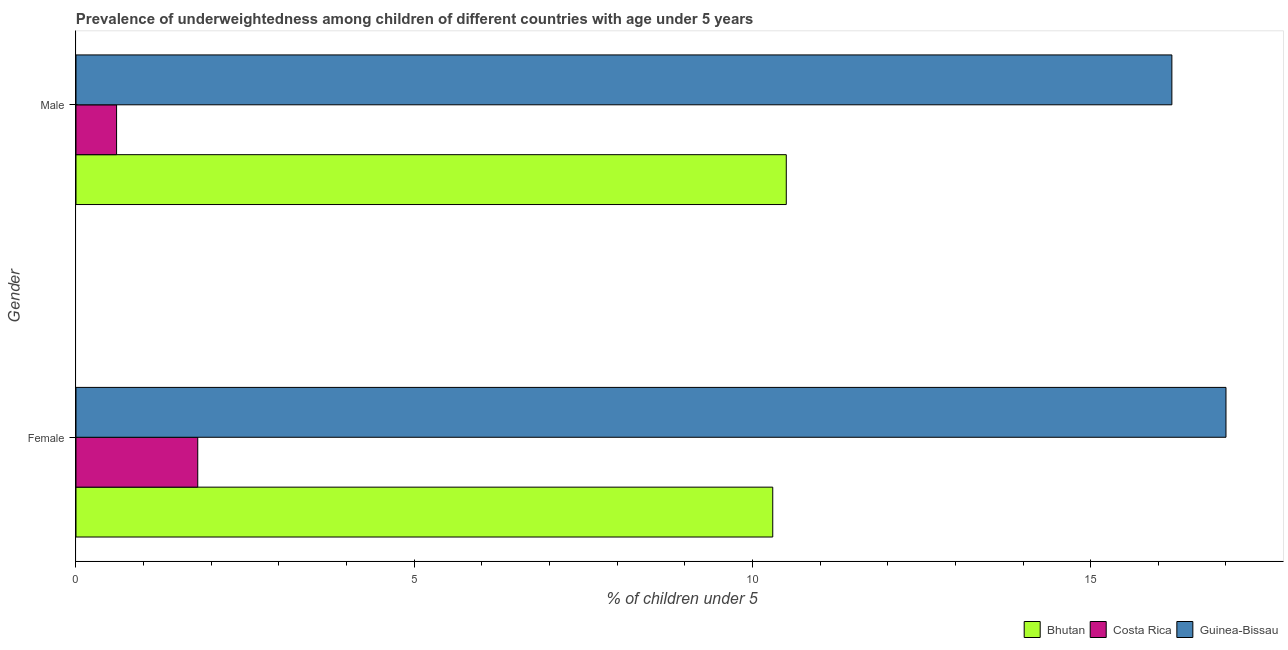Are the number of bars per tick equal to the number of legend labels?
Provide a succinct answer. Yes. How many bars are there on the 2nd tick from the bottom?
Your response must be concise. 3. What is the label of the 1st group of bars from the top?
Give a very brief answer. Male. What is the percentage of underweighted male children in Costa Rica?
Provide a short and direct response. 0.6. Across all countries, what is the maximum percentage of underweighted male children?
Offer a very short reply. 16.2. Across all countries, what is the minimum percentage of underweighted female children?
Your answer should be very brief. 1.8. In which country was the percentage of underweighted male children maximum?
Offer a terse response. Guinea-Bissau. What is the total percentage of underweighted male children in the graph?
Your answer should be very brief. 27.3. What is the difference between the percentage of underweighted male children in Bhutan and that in Guinea-Bissau?
Make the answer very short. -5.7. What is the difference between the percentage of underweighted male children in Bhutan and the percentage of underweighted female children in Costa Rica?
Provide a short and direct response. 8.7. What is the average percentage of underweighted female children per country?
Make the answer very short. 9.7. What is the difference between the percentage of underweighted male children and percentage of underweighted female children in Bhutan?
Your answer should be very brief. 0.2. In how many countries, is the percentage of underweighted female children greater than 14 %?
Your answer should be compact. 1. What is the ratio of the percentage of underweighted female children in Bhutan to that in Costa Rica?
Give a very brief answer. 5.72. Is the percentage of underweighted male children in Guinea-Bissau less than that in Bhutan?
Offer a terse response. No. What does the 2nd bar from the top in Female represents?
Give a very brief answer. Costa Rica. What does the 3rd bar from the bottom in Female represents?
Make the answer very short. Guinea-Bissau. Does the graph contain any zero values?
Provide a short and direct response. No. Does the graph contain grids?
Make the answer very short. No. How are the legend labels stacked?
Keep it short and to the point. Horizontal. What is the title of the graph?
Your response must be concise. Prevalence of underweightedness among children of different countries with age under 5 years. Does "European Union" appear as one of the legend labels in the graph?
Your response must be concise. No. What is the label or title of the X-axis?
Ensure brevity in your answer.   % of children under 5. What is the label or title of the Y-axis?
Your answer should be compact. Gender. What is the  % of children under 5 of Bhutan in Female?
Provide a short and direct response. 10.3. What is the  % of children under 5 of Costa Rica in Female?
Make the answer very short. 1.8. What is the  % of children under 5 in Bhutan in Male?
Keep it short and to the point. 10.5. What is the  % of children under 5 of Costa Rica in Male?
Your answer should be compact. 0.6. What is the  % of children under 5 of Guinea-Bissau in Male?
Make the answer very short. 16.2. Across all Gender, what is the maximum  % of children under 5 of Bhutan?
Your answer should be compact. 10.5. Across all Gender, what is the maximum  % of children under 5 in Costa Rica?
Give a very brief answer. 1.8. Across all Gender, what is the minimum  % of children under 5 in Bhutan?
Your answer should be compact. 10.3. Across all Gender, what is the minimum  % of children under 5 in Costa Rica?
Offer a very short reply. 0.6. Across all Gender, what is the minimum  % of children under 5 of Guinea-Bissau?
Your response must be concise. 16.2. What is the total  % of children under 5 in Bhutan in the graph?
Provide a short and direct response. 20.8. What is the total  % of children under 5 in Guinea-Bissau in the graph?
Your response must be concise. 33.2. What is the difference between the  % of children under 5 of Costa Rica in Female and that in Male?
Your answer should be compact. 1.2. What is the difference between the  % of children under 5 in Guinea-Bissau in Female and that in Male?
Provide a succinct answer. 0.8. What is the difference between the  % of children under 5 of Bhutan in Female and the  % of children under 5 of Costa Rica in Male?
Offer a very short reply. 9.7. What is the difference between the  % of children under 5 of Bhutan in Female and the  % of children under 5 of Guinea-Bissau in Male?
Give a very brief answer. -5.9. What is the difference between the  % of children under 5 in Costa Rica in Female and the  % of children under 5 in Guinea-Bissau in Male?
Your answer should be very brief. -14.4. What is the difference between the  % of children under 5 in Costa Rica and  % of children under 5 in Guinea-Bissau in Female?
Make the answer very short. -15.2. What is the difference between the  % of children under 5 in Bhutan and  % of children under 5 in Costa Rica in Male?
Your response must be concise. 9.9. What is the difference between the  % of children under 5 of Bhutan and  % of children under 5 of Guinea-Bissau in Male?
Offer a very short reply. -5.7. What is the difference between the  % of children under 5 in Costa Rica and  % of children under 5 in Guinea-Bissau in Male?
Your answer should be compact. -15.6. What is the ratio of the  % of children under 5 of Guinea-Bissau in Female to that in Male?
Offer a terse response. 1.05. What is the difference between the highest and the second highest  % of children under 5 of Costa Rica?
Ensure brevity in your answer.  1.2. What is the difference between the highest and the second highest  % of children under 5 in Guinea-Bissau?
Provide a short and direct response. 0.8. What is the difference between the highest and the lowest  % of children under 5 of Bhutan?
Provide a short and direct response. 0.2. What is the difference between the highest and the lowest  % of children under 5 of Costa Rica?
Keep it short and to the point. 1.2. 